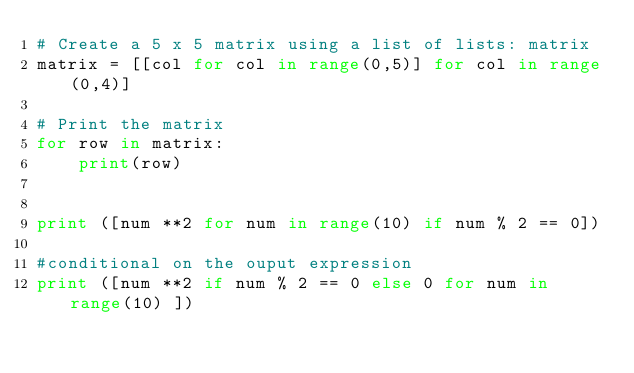<code> <loc_0><loc_0><loc_500><loc_500><_Python_># Create a 5 x 5 matrix using a list of lists: matrix
matrix = [[col for col in range(0,5)] for col in range(0,4)]

# Print the matrix
for row in matrix:
    print(row)


print ([num **2 for num in range(10) if num % 2 == 0])

#conditional on the ouput expression
print ([num **2 if num % 2 == 0 else 0 for num in range(10) ])

</code> 